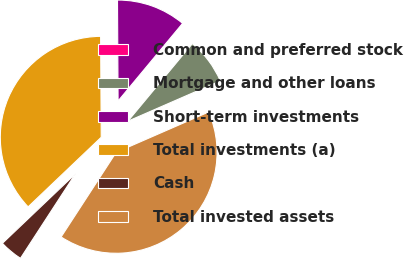Convert chart to OTSL. <chart><loc_0><loc_0><loc_500><loc_500><pie_chart><fcel>Common and preferred stock<fcel>Mortgage and other loans<fcel>Short-term investments<fcel>Total investments (a)<fcel>Cash<fcel>Total invested assets<nl><fcel>0.0%<fcel>7.42%<fcel>11.13%<fcel>37.02%<fcel>3.71%<fcel>40.73%<nl></chart> 